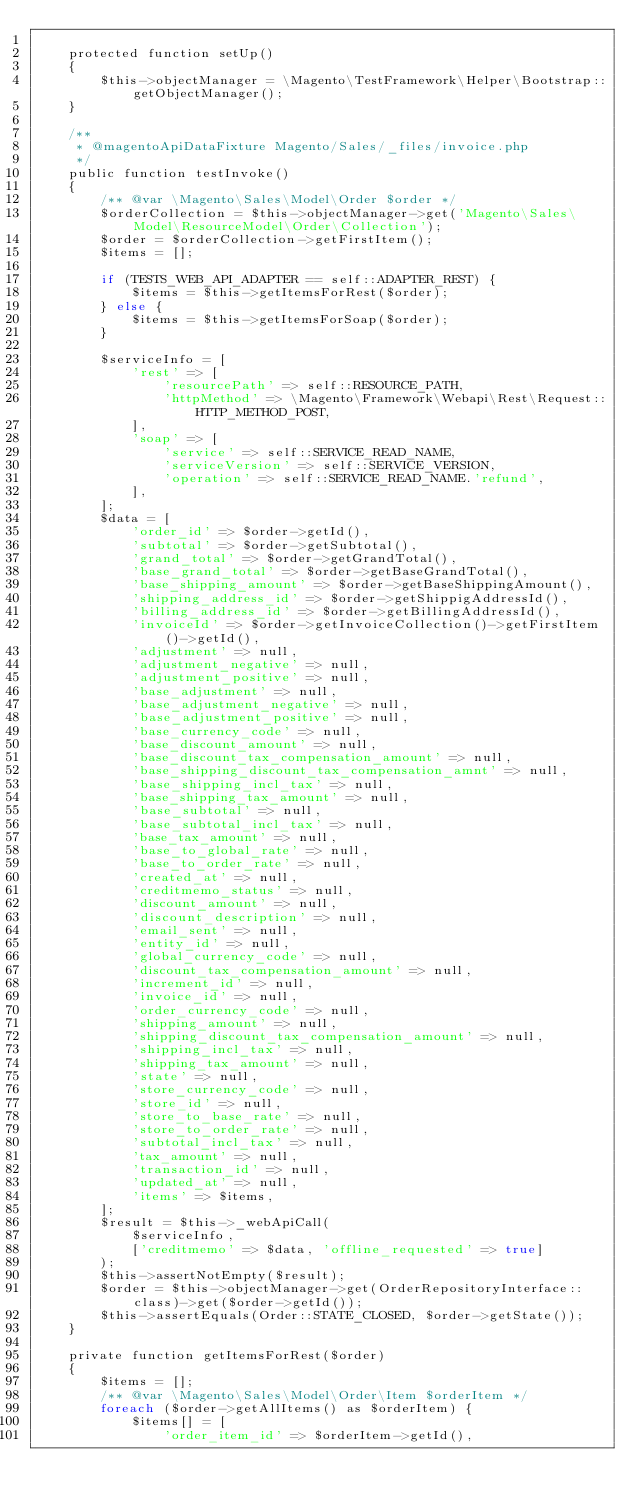<code> <loc_0><loc_0><loc_500><loc_500><_PHP_>
    protected function setUp()
    {
        $this->objectManager = \Magento\TestFramework\Helper\Bootstrap::getObjectManager();
    }

    /**
     * @magentoApiDataFixture Magento/Sales/_files/invoice.php
     */
    public function testInvoke()
    {
        /** @var \Magento\Sales\Model\Order $order */
        $orderCollection = $this->objectManager->get('Magento\Sales\Model\ResourceModel\Order\Collection');
        $order = $orderCollection->getFirstItem();
        $items = [];

        if (TESTS_WEB_API_ADAPTER == self::ADAPTER_REST) {
            $items = $this->getItemsForRest($order);
        } else {
            $items = $this->getItemsForSoap($order);
        }

        $serviceInfo = [
            'rest' => [
                'resourcePath' => self::RESOURCE_PATH,
                'httpMethod' => \Magento\Framework\Webapi\Rest\Request::HTTP_METHOD_POST,
            ],
            'soap' => [
                'service' => self::SERVICE_READ_NAME,
                'serviceVersion' => self::SERVICE_VERSION,
                'operation' => self::SERVICE_READ_NAME.'refund',
            ],
        ];
        $data = [
            'order_id' => $order->getId(),
            'subtotal' => $order->getSubtotal(),
            'grand_total' => $order->getGrandTotal(),
            'base_grand_total' => $order->getBaseGrandTotal(),
            'base_shipping_amount' => $order->getBaseShippingAmount(),
            'shipping_address_id' => $order->getShippigAddressId(),
            'billing_address_id' => $order->getBillingAddressId(),
            'invoiceId' => $order->getInvoiceCollection()->getFirstItem()->getId(),
            'adjustment' => null,
            'adjustment_negative' => null,
            'adjustment_positive' => null,
            'base_adjustment' => null,
            'base_adjustment_negative' => null,
            'base_adjustment_positive' => null,
            'base_currency_code' => null,
            'base_discount_amount' => null,
            'base_discount_tax_compensation_amount' => null,
            'base_shipping_discount_tax_compensation_amnt' => null,
            'base_shipping_incl_tax' => null,
            'base_shipping_tax_amount' => null,
            'base_subtotal' => null,
            'base_subtotal_incl_tax' => null,
            'base_tax_amount' => null,
            'base_to_global_rate' => null,
            'base_to_order_rate' => null,
            'created_at' => null,
            'creditmemo_status' => null,
            'discount_amount' => null,
            'discount_description' => null,
            'email_sent' => null,
            'entity_id' => null,
            'global_currency_code' => null,
            'discount_tax_compensation_amount' => null,
            'increment_id' => null,
            'invoice_id' => null,
            'order_currency_code' => null,
            'shipping_amount' => null,
            'shipping_discount_tax_compensation_amount' => null,
            'shipping_incl_tax' => null,
            'shipping_tax_amount' => null,
            'state' => null,
            'store_currency_code' => null,
            'store_id' => null,
            'store_to_base_rate' => null,
            'store_to_order_rate' => null,
            'subtotal_incl_tax' => null,
            'tax_amount' => null,
            'transaction_id' => null,
            'updated_at' => null,
            'items' => $items,
        ];
        $result = $this->_webApiCall(
            $serviceInfo,
            ['creditmemo' => $data, 'offline_requested' => true]
        );
        $this->assertNotEmpty($result);
        $order = $this->objectManager->get(OrderRepositoryInterface::class)->get($order->getId());
        $this->assertEquals(Order::STATE_CLOSED, $order->getState());
    }

    private function getItemsForRest($order)
    {
        $items = [];
        /** @var \Magento\Sales\Model\Order\Item $orderItem */
        foreach ($order->getAllItems() as $orderItem) {
            $items[] = [
                'order_item_id' => $orderItem->getId(),</code> 